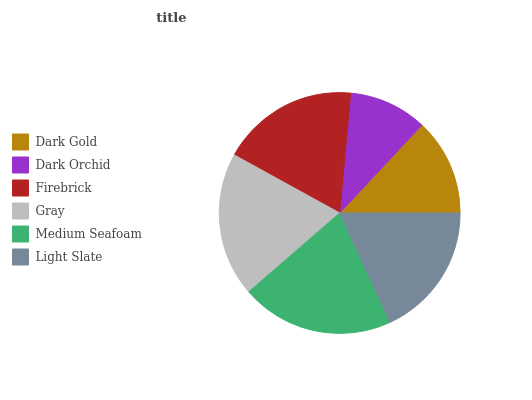Is Dark Orchid the minimum?
Answer yes or no. Yes. Is Medium Seafoam the maximum?
Answer yes or no. Yes. Is Firebrick the minimum?
Answer yes or no. No. Is Firebrick the maximum?
Answer yes or no. No. Is Firebrick greater than Dark Orchid?
Answer yes or no. Yes. Is Dark Orchid less than Firebrick?
Answer yes or no. Yes. Is Dark Orchid greater than Firebrick?
Answer yes or no. No. Is Firebrick less than Dark Orchid?
Answer yes or no. No. Is Firebrick the high median?
Answer yes or no. Yes. Is Light Slate the low median?
Answer yes or no. Yes. Is Dark Gold the high median?
Answer yes or no. No. Is Medium Seafoam the low median?
Answer yes or no. No. 